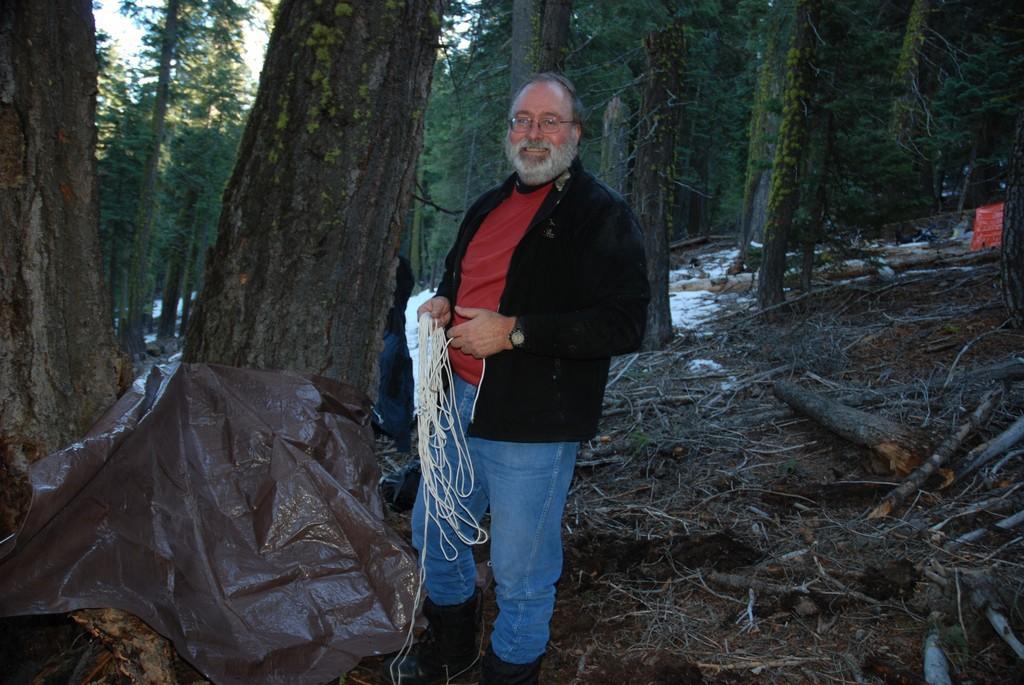In one or two sentences, can you explain what this image depicts? In this picture we can see a man wore spectacles, holding a rope with his hands, standing on the ground and smiling. In the background we can see a person, wooden logs, plastic sheet, trees, some objects and the sky. 